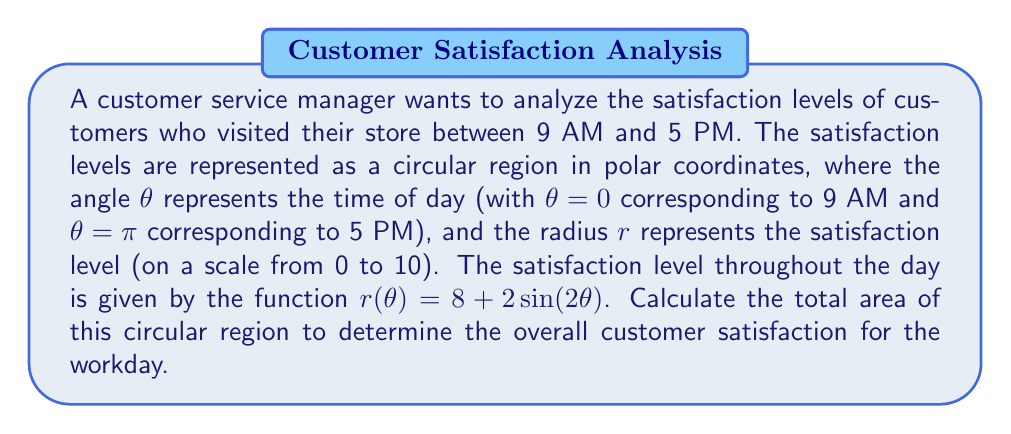Teach me how to tackle this problem. To solve this problem, we'll use the formula for the area of a region in polar coordinates:

$$A = \frac{1}{2} \int_a^b [r(\theta)]^2 d\theta$$

Where:
- $a$ is the starting angle (9 AM = 0)
- $b$ is the ending angle (5 PM = $\pi$)
- $r(\theta) = 8 + 2\sin(2\theta)$

Steps:
1) Substitute the given function into the area formula:

   $$A = \frac{1}{2} \int_0^\pi [8 + 2\sin(2\theta)]^2 d\theta$$

2) Expand the squared term:

   $$A = \frac{1}{2} \int_0^\pi [64 + 32\sin(2\theta) + 4\sin^2(2\theta)] d\theta$$

3) Integrate each term:
   
   $$A = \frac{1}{2} [64\theta + 32(-\frac{1}{2}\cos(2\theta)) + 4(\frac{\theta}{2} - \frac{1}{4}\sin(4\theta))]_0^\pi$$

4) Evaluate the integral from 0 to $\pi$:

   $$A = \frac{1}{2} [(64\pi + 0 + 2\pi) - (0 + 32 + 0)]$$
   
   $$A = \frac{1}{2} [66\pi - 32]$$

5) Simplify:

   $$A = 33\pi - 16$$

This area represents the overall customer satisfaction for the workday, where larger areas indicate higher overall satisfaction.
Answer: $33\pi - 16$ square units 